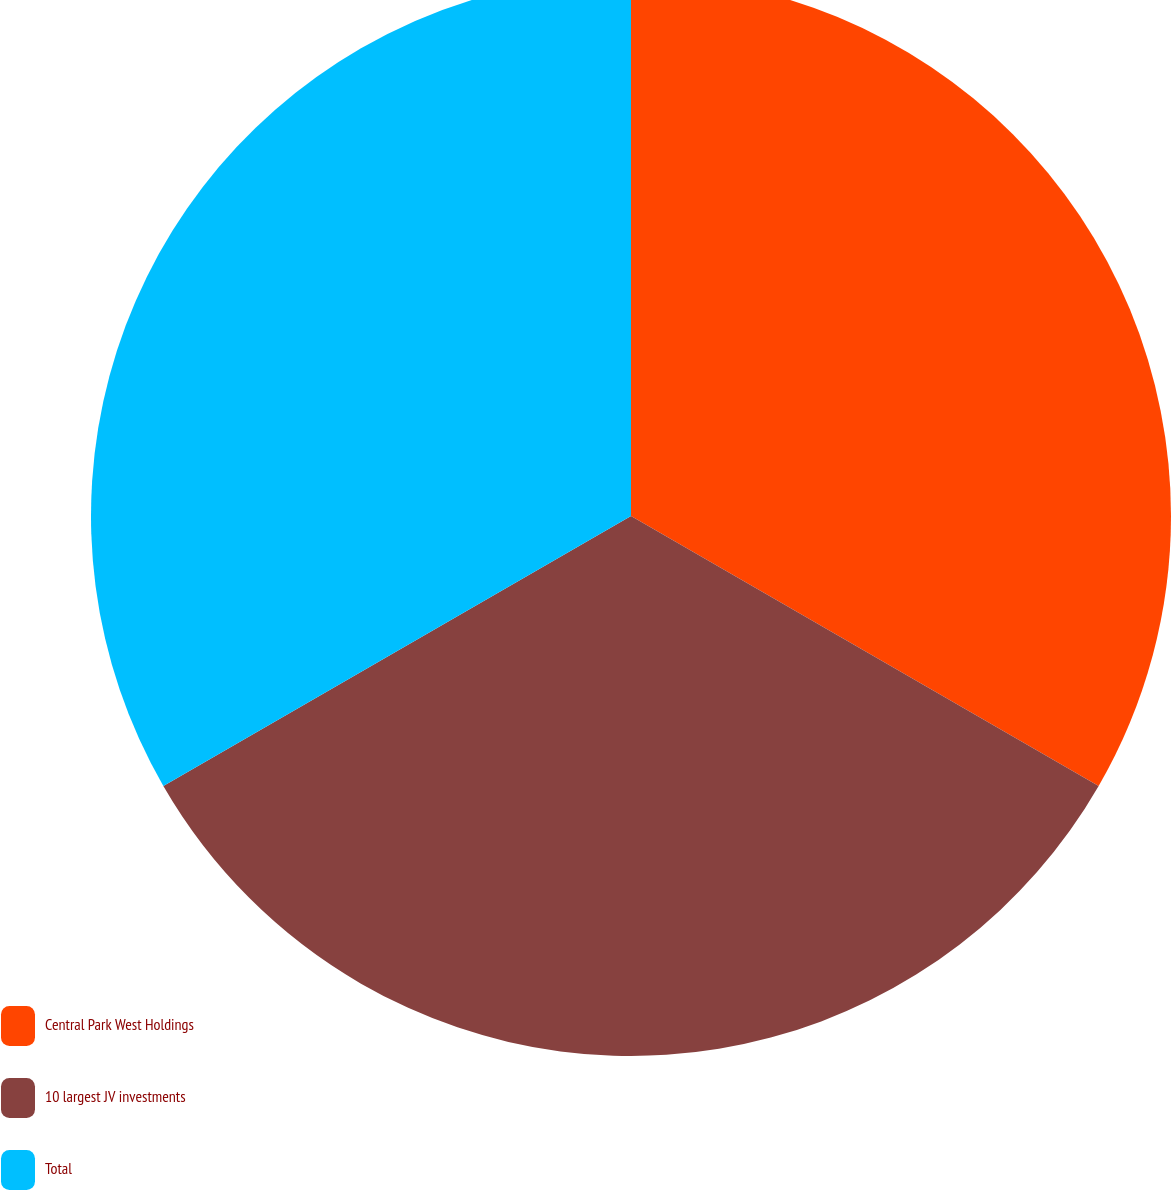Convert chart. <chart><loc_0><loc_0><loc_500><loc_500><pie_chart><fcel>Central Park West Holdings<fcel>10 largest JV investments<fcel>Total<nl><fcel>33.33%<fcel>33.33%<fcel>33.33%<nl></chart> 